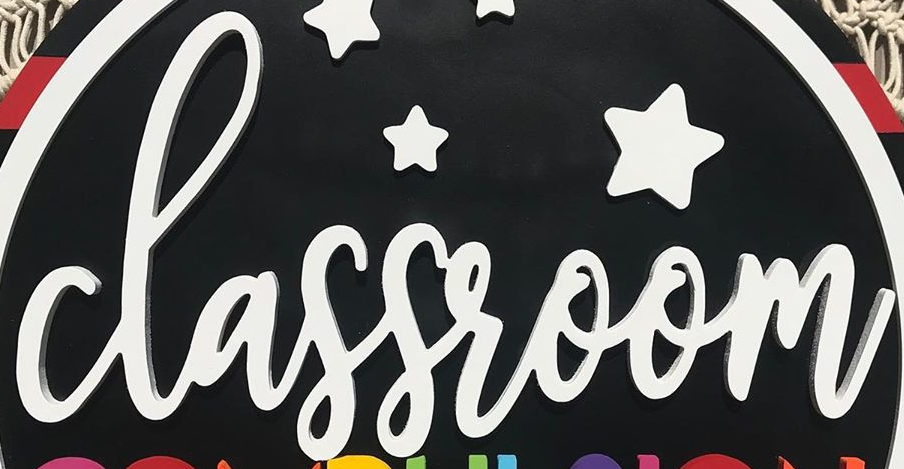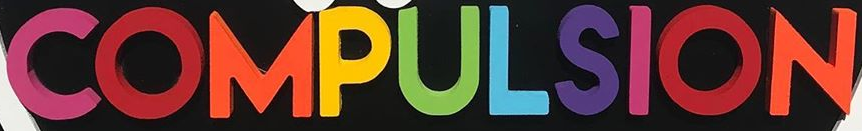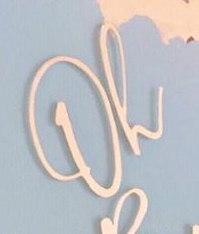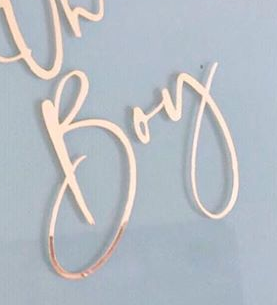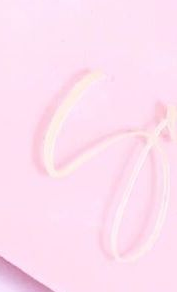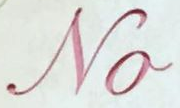Read the text from these images in sequence, separated by a semicolon. classroom; COMPULSION; Oh; Boy; S; No 